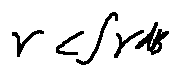Convert formula to latex. <formula><loc_0><loc_0><loc_500><loc_500>r < \int \gamma d B</formula> 